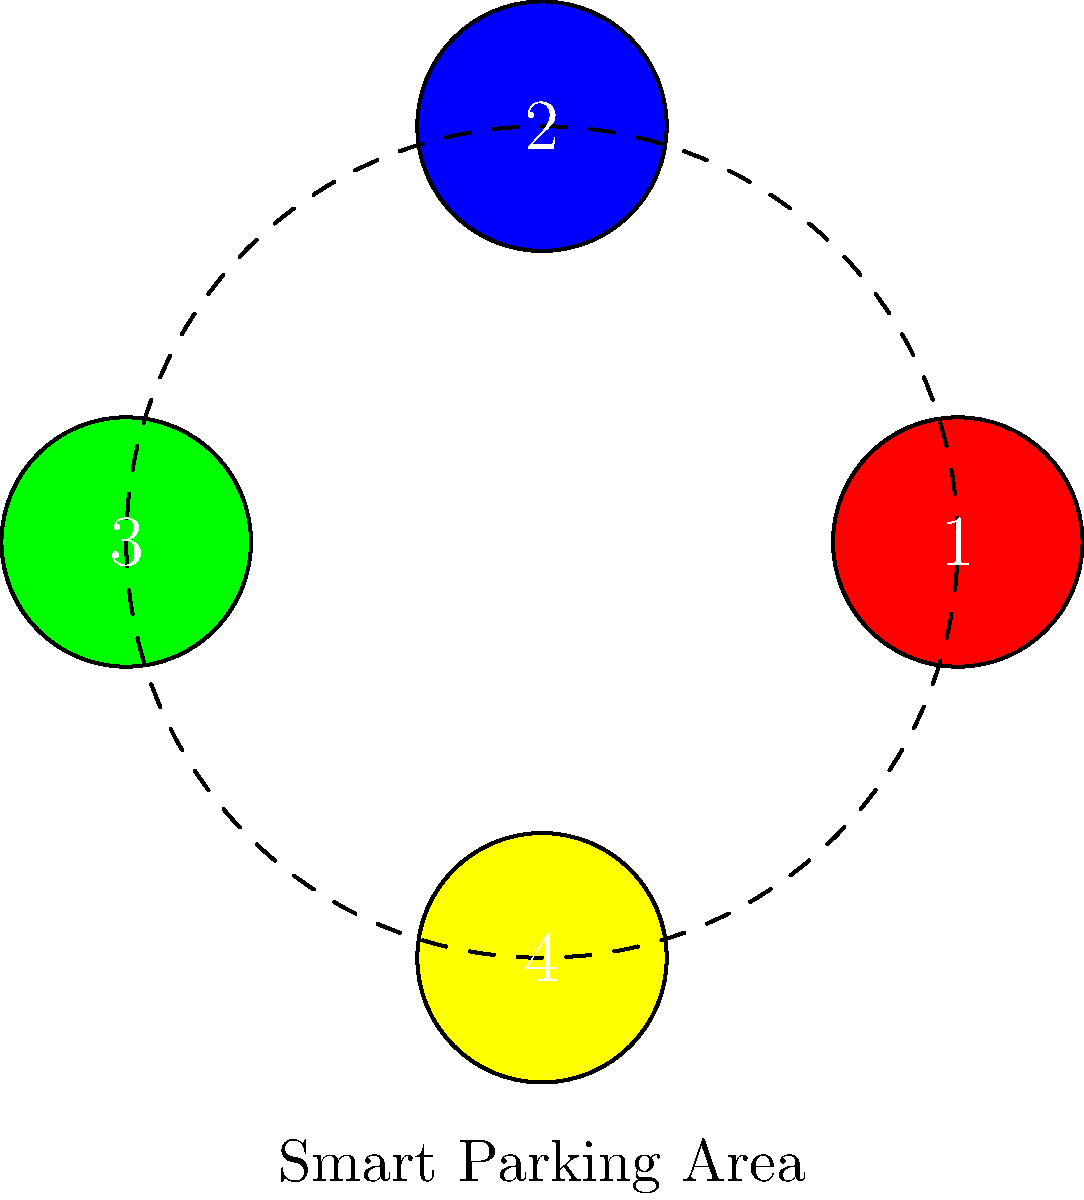A smart parking system for a fleet of 4 electric vehicles uses color-coded spaces arranged in a circular configuration. How many unique arrangements are possible if all 4 spaces must be occupied, and the system considers rotations of the entire configuration as equivalent? Let's approach this step-by-step:

1) First, we need to understand what the question is asking. We have 4 vehicles that can be arranged in 4 parking spaces, and rotations are considered equivalent.

2) Without considering rotations, we would have $4!$ (4 factorial) = 24 possible arrangements.

3) However, rotations are considered equivalent. This means that for each unique arrangement, there are 4 equivalent rotations (including the original position).

4) To find the number of unique arrangements, we need to divide the total number of arrangements by the number of equivalent rotations:

   $\frac{\text{Total arrangements}}{\text{Number of rotations}} = \frac{4!}{4} = \frac{24}{4} = 6$

5) This result can be understood in terms of the orbit-stabilizer theorem from group theory. The group of rotations (cyclic group of order 4) acts on the set of all permutations, and we're counting the number of orbits.

6) Alternatively, we can think of this as fixing the position of one vehicle and permuting the rest, which gives us $3! = 6$ arrangements.

Therefore, there are 6 unique arrangements possible in this smart parking system.
Answer: 6 unique arrangements 